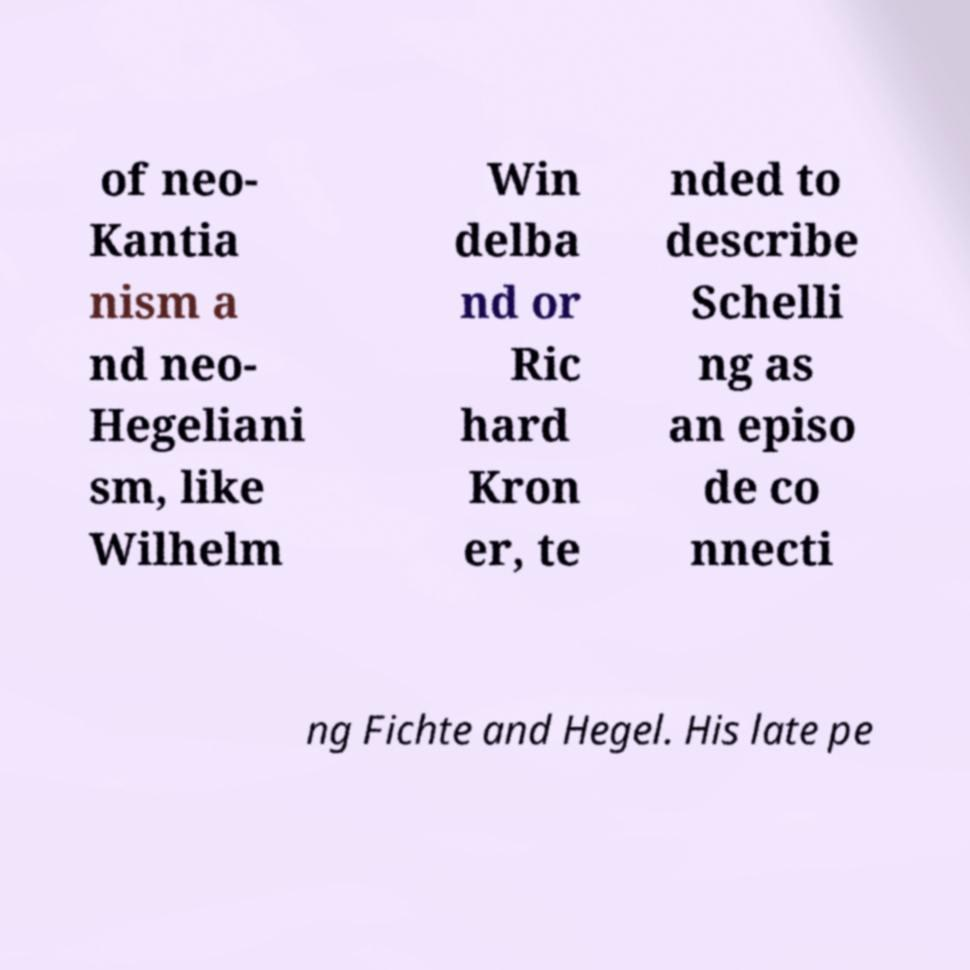Please identify and transcribe the text found in this image. of neo- Kantia nism a nd neo- Hegeliani sm, like Wilhelm Win delba nd or Ric hard Kron er, te nded to describe Schelli ng as an episo de co nnecti ng Fichte and Hegel. His late pe 